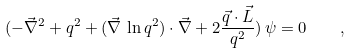<formula> <loc_0><loc_0><loc_500><loc_500>( - \vec { \nabla } ^ { 2 } + q ^ { 2 } + ( \vec { \nabla } \, \ln q ^ { 2 } ) \cdot \vec { \nabla } + 2 \frac { \vec { q } \cdot { \vec { L } } } { q ^ { 2 } } ) \, \psi = 0 \quad ,</formula> 